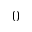<formula> <loc_0><loc_0><loc_500><loc_500>0</formula> 